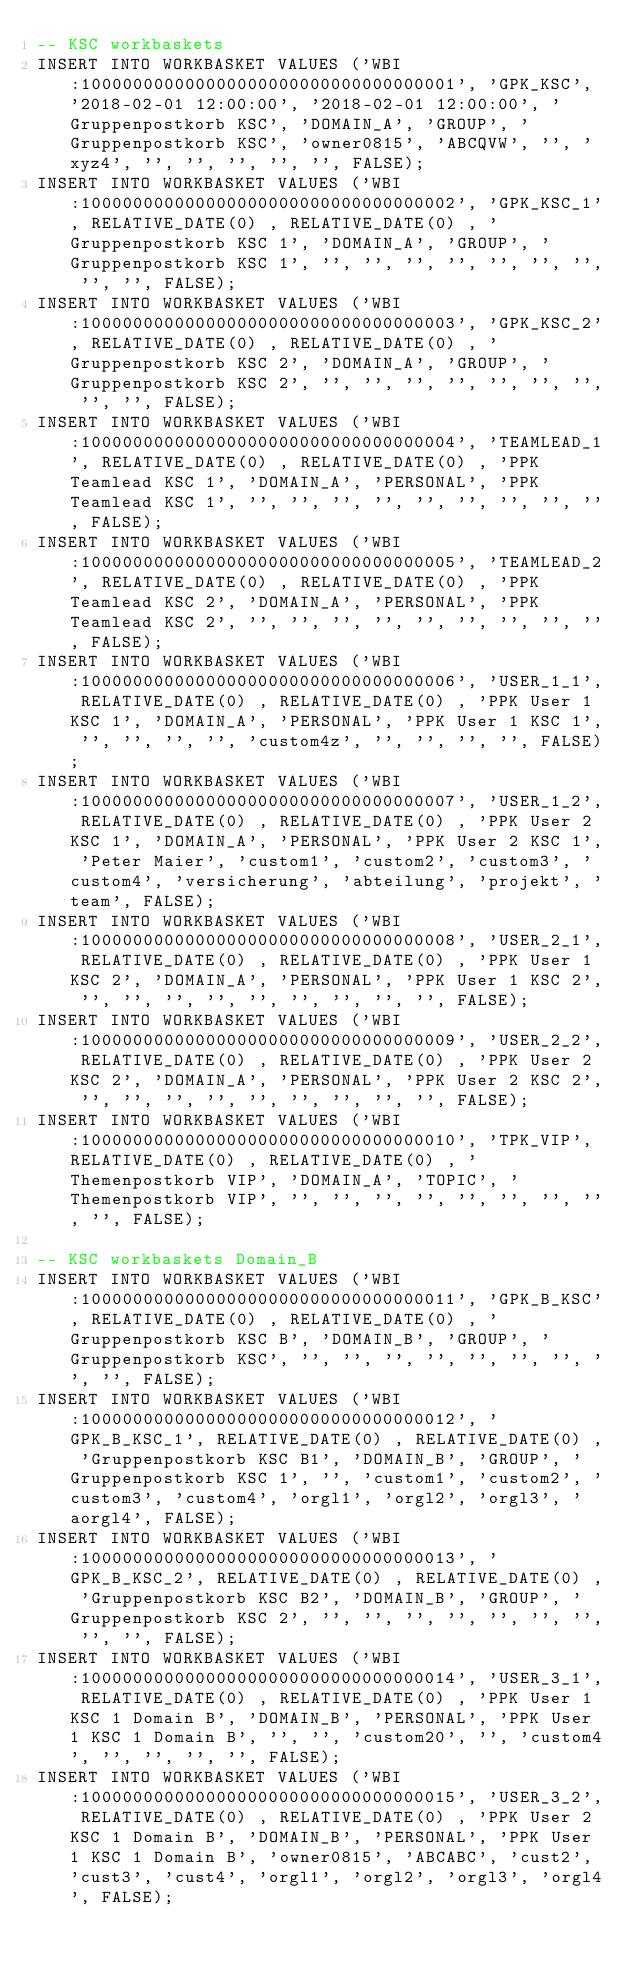Convert code to text. <code><loc_0><loc_0><loc_500><loc_500><_SQL_>-- KSC workbaskets
INSERT INTO WORKBASKET VALUES ('WBI:100000000000000000000000000000000001', 'GPK_KSC', '2018-02-01 12:00:00', '2018-02-01 12:00:00', 'Gruppenpostkorb KSC', 'DOMAIN_A', 'GROUP', 'Gruppenpostkorb KSC', 'owner0815', 'ABCQVW', '', 'xyz4', '', '', '', '', '', FALSE);
INSERT INTO WORKBASKET VALUES ('WBI:100000000000000000000000000000000002', 'GPK_KSC_1', RELATIVE_DATE(0) , RELATIVE_DATE(0) , 'Gruppenpostkorb KSC 1', 'DOMAIN_A', 'GROUP', 'Gruppenpostkorb KSC 1', '', '', '', '', '', '', '', '', '', FALSE);
INSERT INTO WORKBASKET VALUES ('WBI:100000000000000000000000000000000003', 'GPK_KSC_2', RELATIVE_DATE(0) , RELATIVE_DATE(0) , 'Gruppenpostkorb KSC 2', 'DOMAIN_A', 'GROUP', 'Gruppenpostkorb KSC 2', '', '', '', '', '', '', '', '', '', FALSE);
INSERT INTO WORKBASKET VALUES ('WBI:100000000000000000000000000000000004', 'TEAMLEAD_1', RELATIVE_DATE(0) , RELATIVE_DATE(0) , 'PPK Teamlead KSC 1', 'DOMAIN_A', 'PERSONAL', 'PPK Teamlead KSC 1', '', '', '', '', '', '', '', '', '', FALSE);
INSERT INTO WORKBASKET VALUES ('WBI:100000000000000000000000000000000005', 'TEAMLEAD_2', RELATIVE_DATE(0) , RELATIVE_DATE(0) , 'PPK Teamlead KSC 2', 'DOMAIN_A', 'PERSONAL', 'PPK Teamlead KSC 2', '', '', '', '', '', '', '', '', '', FALSE);
INSERT INTO WORKBASKET VALUES ('WBI:100000000000000000000000000000000006', 'USER_1_1', RELATIVE_DATE(0) , RELATIVE_DATE(0) , 'PPK User 1 KSC 1', 'DOMAIN_A', 'PERSONAL', 'PPK User 1 KSC 1', '', '', '', '', 'custom4z', '', '', '', '', FALSE);
INSERT INTO WORKBASKET VALUES ('WBI:100000000000000000000000000000000007', 'USER_1_2', RELATIVE_DATE(0) , RELATIVE_DATE(0) , 'PPK User 2 KSC 1', 'DOMAIN_A', 'PERSONAL', 'PPK User 2 KSC 1', 'Peter Maier', 'custom1', 'custom2', 'custom3', 'custom4', 'versicherung', 'abteilung', 'projekt', 'team', FALSE);
INSERT INTO WORKBASKET VALUES ('WBI:100000000000000000000000000000000008', 'USER_2_1', RELATIVE_DATE(0) , RELATIVE_DATE(0) , 'PPK User 1 KSC 2', 'DOMAIN_A', 'PERSONAL', 'PPK User 1 KSC 2', '', '', '', '', '', '', '', '', '', FALSE);
INSERT INTO WORKBASKET VALUES ('WBI:100000000000000000000000000000000009', 'USER_2_2', RELATIVE_DATE(0) , RELATIVE_DATE(0) , 'PPK User 2 KSC 2', 'DOMAIN_A', 'PERSONAL', 'PPK User 2 KSC 2', '', '', '', '', '', '', '', '', '', FALSE);
INSERT INTO WORKBASKET VALUES ('WBI:100000000000000000000000000000000010', 'TPK_VIP', RELATIVE_DATE(0) , RELATIVE_DATE(0) , 'Themenpostkorb VIP', 'DOMAIN_A', 'TOPIC', 'Themenpostkorb VIP', '', '', '', '', '', '', '', '', '', FALSE);

-- KSC workbaskets Domain_B
INSERT INTO WORKBASKET VALUES ('WBI:100000000000000000000000000000000011', 'GPK_B_KSC', RELATIVE_DATE(0) , RELATIVE_DATE(0) , 'Gruppenpostkorb KSC B', 'DOMAIN_B', 'GROUP', 'Gruppenpostkorb KSC', '', '', '', '', '', '', '', '', '', FALSE);
INSERT INTO WORKBASKET VALUES ('WBI:100000000000000000000000000000000012', 'GPK_B_KSC_1', RELATIVE_DATE(0) , RELATIVE_DATE(0) , 'Gruppenpostkorb KSC B1', 'DOMAIN_B', 'GROUP', 'Gruppenpostkorb KSC 1', '', 'custom1', 'custom2', 'custom3', 'custom4', 'orgl1', 'orgl2', 'orgl3', 'aorgl4', FALSE);
INSERT INTO WORKBASKET VALUES ('WBI:100000000000000000000000000000000013', 'GPK_B_KSC_2', RELATIVE_DATE(0) , RELATIVE_DATE(0) , 'Gruppenpostkorb KSC B2', 'DOMAIN_B', 'GROUP', 'Gruppenpostkorb KSC 2', '', '', '', '', '', '', '', '', '', FALSE);
INSERT INTO WORKBASKET VALUES ('WBI:100000000000000000000000000000000014', 'USER_3_1', RELATIVE_DATE(0) , RELATIVE_DATE(0) , 'PPK User 1 KSC 1 Domain B', 'DOMAIN_B', 'PERSONAL', 'PPK User 1 KSC 1 Domain B', '', '', 'custom20', '', 'custom4', '', '', '', '', FALSE);
INSERT INTO WORKBASKET VALUES ('WBI:100000000000000000000000000000000015', 'USER_3_2', RELATIVE_DATE(0) , RELATIVE_DATE(0) , 'PPK User 2 KSC 1 Domain B', 'DOMAIN_B', 'PERSONAL', 'PPK User 1 KSC 1 Domain B', 'owner0815', 'ABCABC', 'cust2', 'cust3', 'cust4', 'orgl1', 'orgl2', 'orgl3', 'orgl4', FALSE);
</code> 